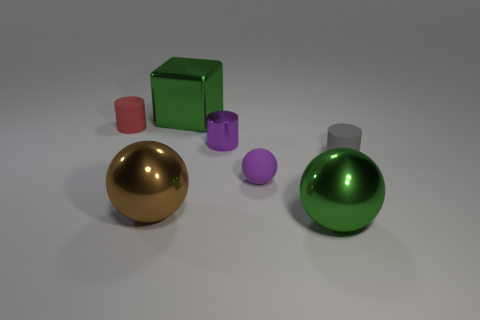What shape is the metal object that is the same color as the tiny sphere?
Offer a terse response. Cylinder. There is a ball that is the same color as the tiny shiny object; what is it made of?
Your answer should be very brief. Rubber. What is the color of the rubber cylinder to the right of the small cylinder left of the big green metallic thing that is behind the gray thing?
Offer a very short reply. Gray. What number of small red things are there?
Your answer should be very brief. 1. How many small objects are either yellow metallic cubes or green metallic objects?
Your answer should be compact. 0. What shape is the red object that is the same size as the rubber sphere?
Ensure brevity in your answer.  Cylinder. Are there any other things that have the same size as the red thing?
Ensure brevity in your answer.  Yes. What material is the green object that is to the left of the tiny purple matte object that is in front of the gray cylinder?
Your answer should be very brief. Metal. Do the green metal ball and the green shiny cube have the same size?
Provide a succinct answer. Yes. How many things are green metal things behind the tiny gray matte thing or green metal objects?
Your answer should be compact. 2. 